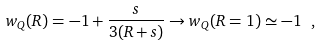<formula> <loc_0><loc_0><loc_500><loc_500>w _ { Q } ( R ) = - 1 + \frac { s } { 3 ( R + s ) } \rightarrow w _ { Q } ( R = 1 ) \simeq - 1 \ ,</formula> 